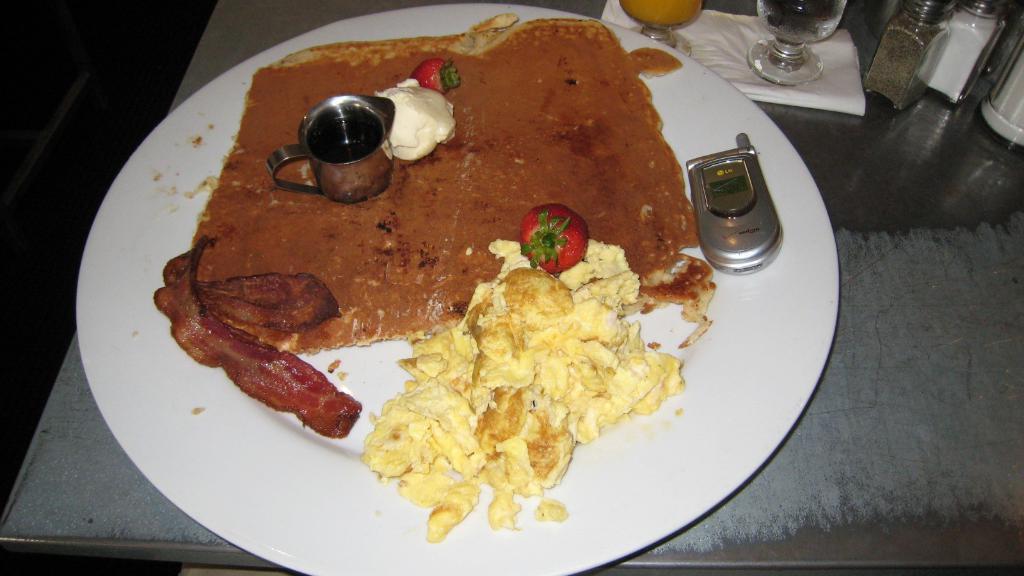Could you give a brief overview of what you see in this image? In this image we can see a table. On the table there are serving plate with food and a mobile phone on it, glass tumblers placed on a paper napkin and sprinklers. 